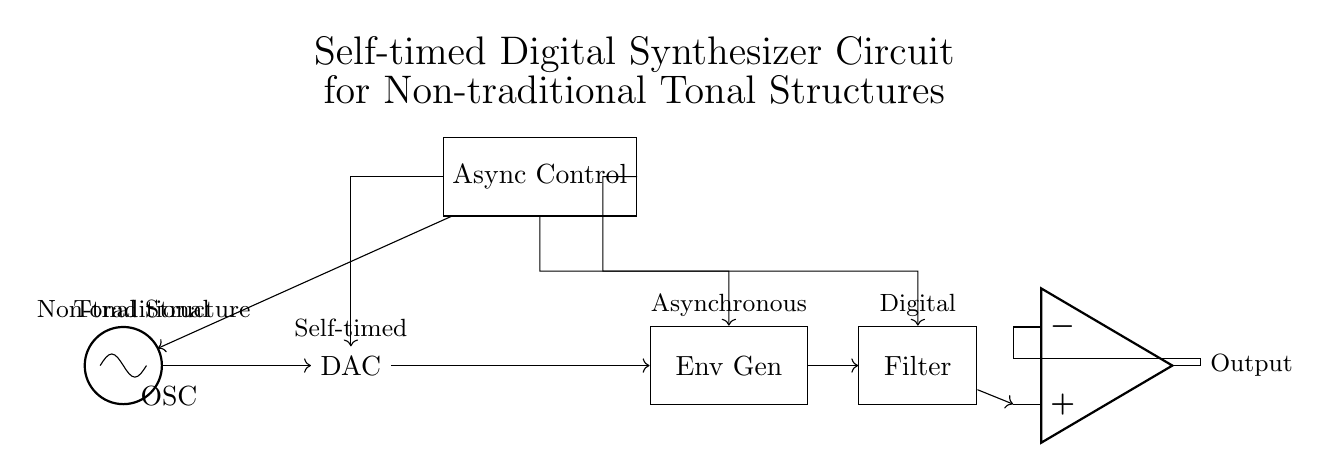What is the output component in the circuit? The output component is represented by the operational amplifier symbol, indicating it amplifies the synthesized signal before output.
Answer: Operational amplifier What component generates the control signals for the circuit? The Asynchronous Control Unit is responsible for generating the necessary control signals to regulate the behavior of the oscillator and other components.
Answer: Async Control How many main signal processing stages are there in the circuit? The circuit has four main signal processing stages: oscillator, digital-to-analog converter, envelope generator, and filter.
Answer: Four What is the function of the Envelope Generator? The Envelope Generator shapes the amplitude of the signal over time, controlling aspects such as attack, decay, sustain, and release of the sound.
Answer: Amplitude shaping Which unit directly connects to the Digital-to-Analog Converter? The oscillator directly supplies a signal to the digital-to-analog converter, where the digital signal is converted into an analog wave.
Answer: Oscillator What type of synthesis does this circuit facilitate? This circuit facilitates non-traditional tonal structures, allowing for sound generation that deviates from conventional tuning and arrangements.
Answer: Non-traditional tonal structures What is the purpose of the filter in the circuit? The Filter modifies the frequency content of the signal by removing unwanted frequencies or enhancing certain ranges to shape the final sound output.
Answer: Frequency modification 